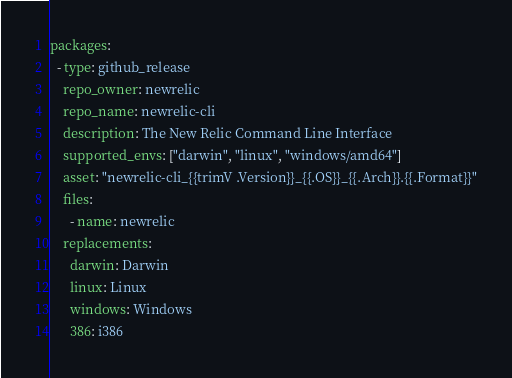Convert code to text. <code><loc_0><loc_0><loc_500><loc_500><_YAML_>packages:
  - type: github_release
    repo_owner: newrelic
    repo_name: newrelic-cli
    description: The New Relic Command Line Interface
    supported_envs: ["darwin", "linux", "windows/amd64"]
    asset: "newrelic-cli_{{trimV .Version}}_{{.OS}}_{{.Arch}}.{{.Format}}"
    files:
      - name: newrelic
    replacements:
      darwin: Darwin
      linux: Linux
      windows: Windows
      386: i386</code> 